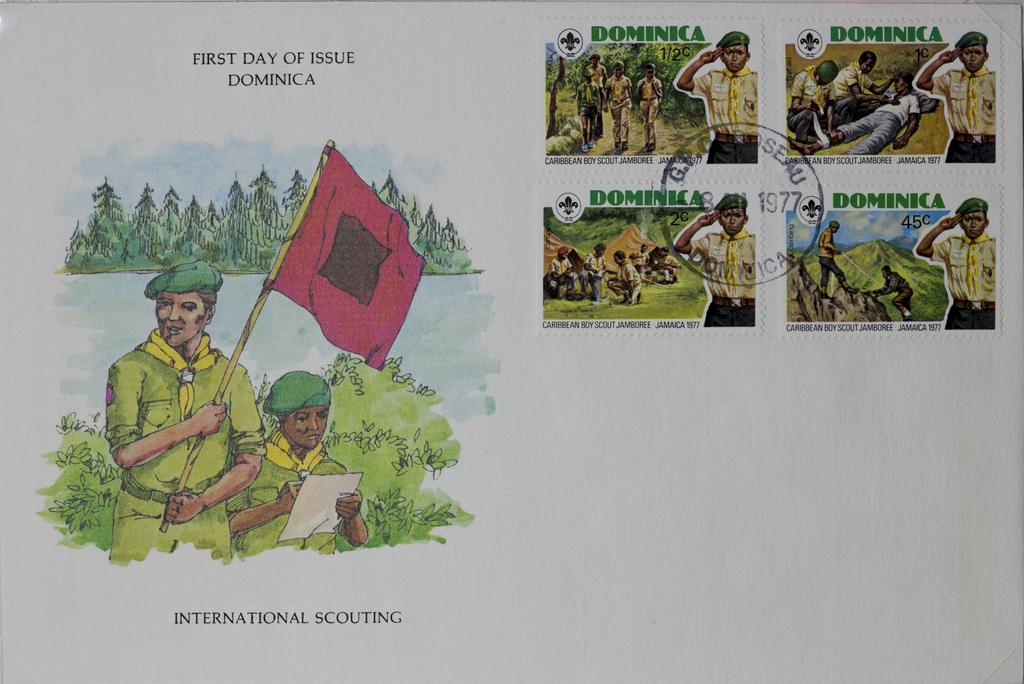<image>
Give a short and clear explanation of the subsequent image. A post card with boy scouts on it is stamped in 1977. 